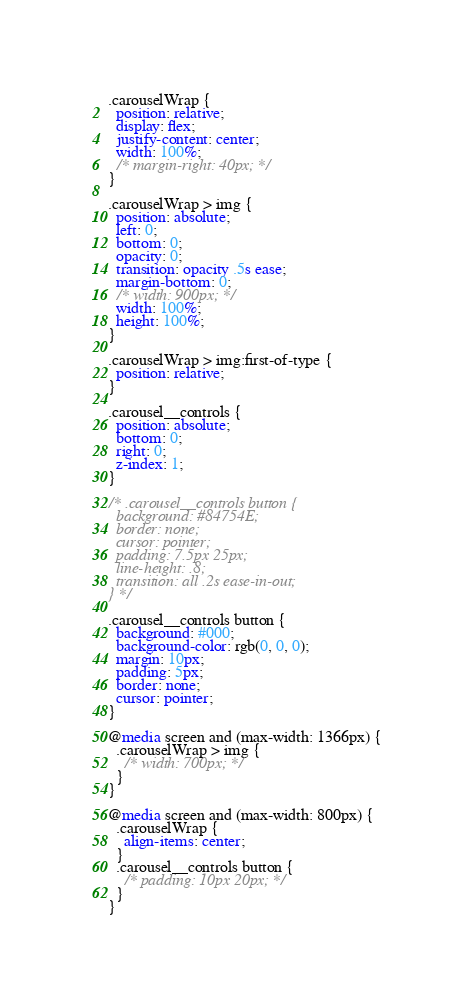<code> <loc_0><loc_0><loc_500><loc_500><_CSS_>.carouselWrap {
  position: relative;
  display: flex;
  justify-content: center;
  width: 100%;
  /* margin-right: 40px; */
}

.carouselWrap > img {
  position: absolute;
  left: 0;
  bottom: 0;
  opacity: 0;
  transition: opacity .5s ease;
  margin-bottom: 0;
  /* width: 900px; */
  width: 100%;
  height: 100%;
}

.carouselWrap > img:first-of-type {
  position: relative;
}

.carousel__controls {
  position: absolute;
  bottom: 0;
  right: 0;
  z-index: 1;
}

/* .carousel__controls button {
  background: #84754E;
  border: none;
  cursor: pointer;
  padding: 7.5px 25px;
  line-height: .8;
  transition: all .2s ease-in-out;
} */

.carousel__controls button {
  background: #000;
  background-color: rgb(0, 0, 0);
  margin: 10px;
  padding: 5px;
  border: none;
  cursor: pointer;
}

@media screen and (max-width: 1366px) {
  .carouselWrap > img {
    /* width: 700px; */
  }
}

@media screen and (max-width: 800px) {
  .carouselWrap {
    align-items: center;
  }
  .carousel__controls button {
    /* padding: 10px 20px; */
  }
}</code> 